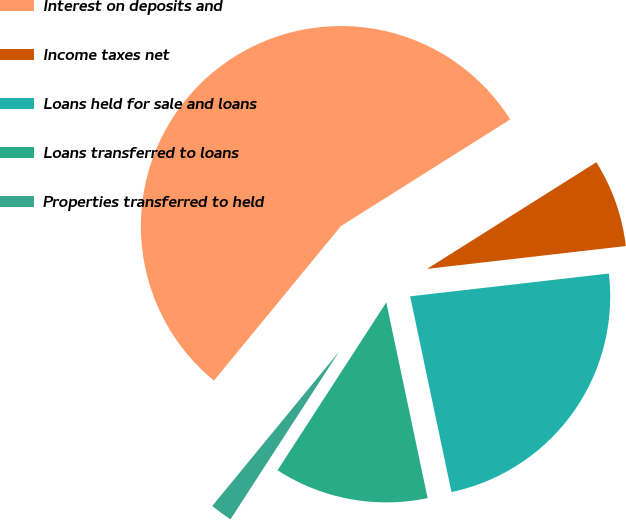Convert chart to OTSL. <chart><loc_0><loc_0><loc_500><loc_500><pie_chart><fcel>Interest on deposits and<fcel>Income taxes net<fcel>Loans held for sale and loans<fcel>Loans transferred to loans<fcel>Properties transferred to held<nl><fcel>55.11%<fcel>7.13%<fcel>23.51%<fcel>12.46%<fcel>1.8%<nl></chart> 